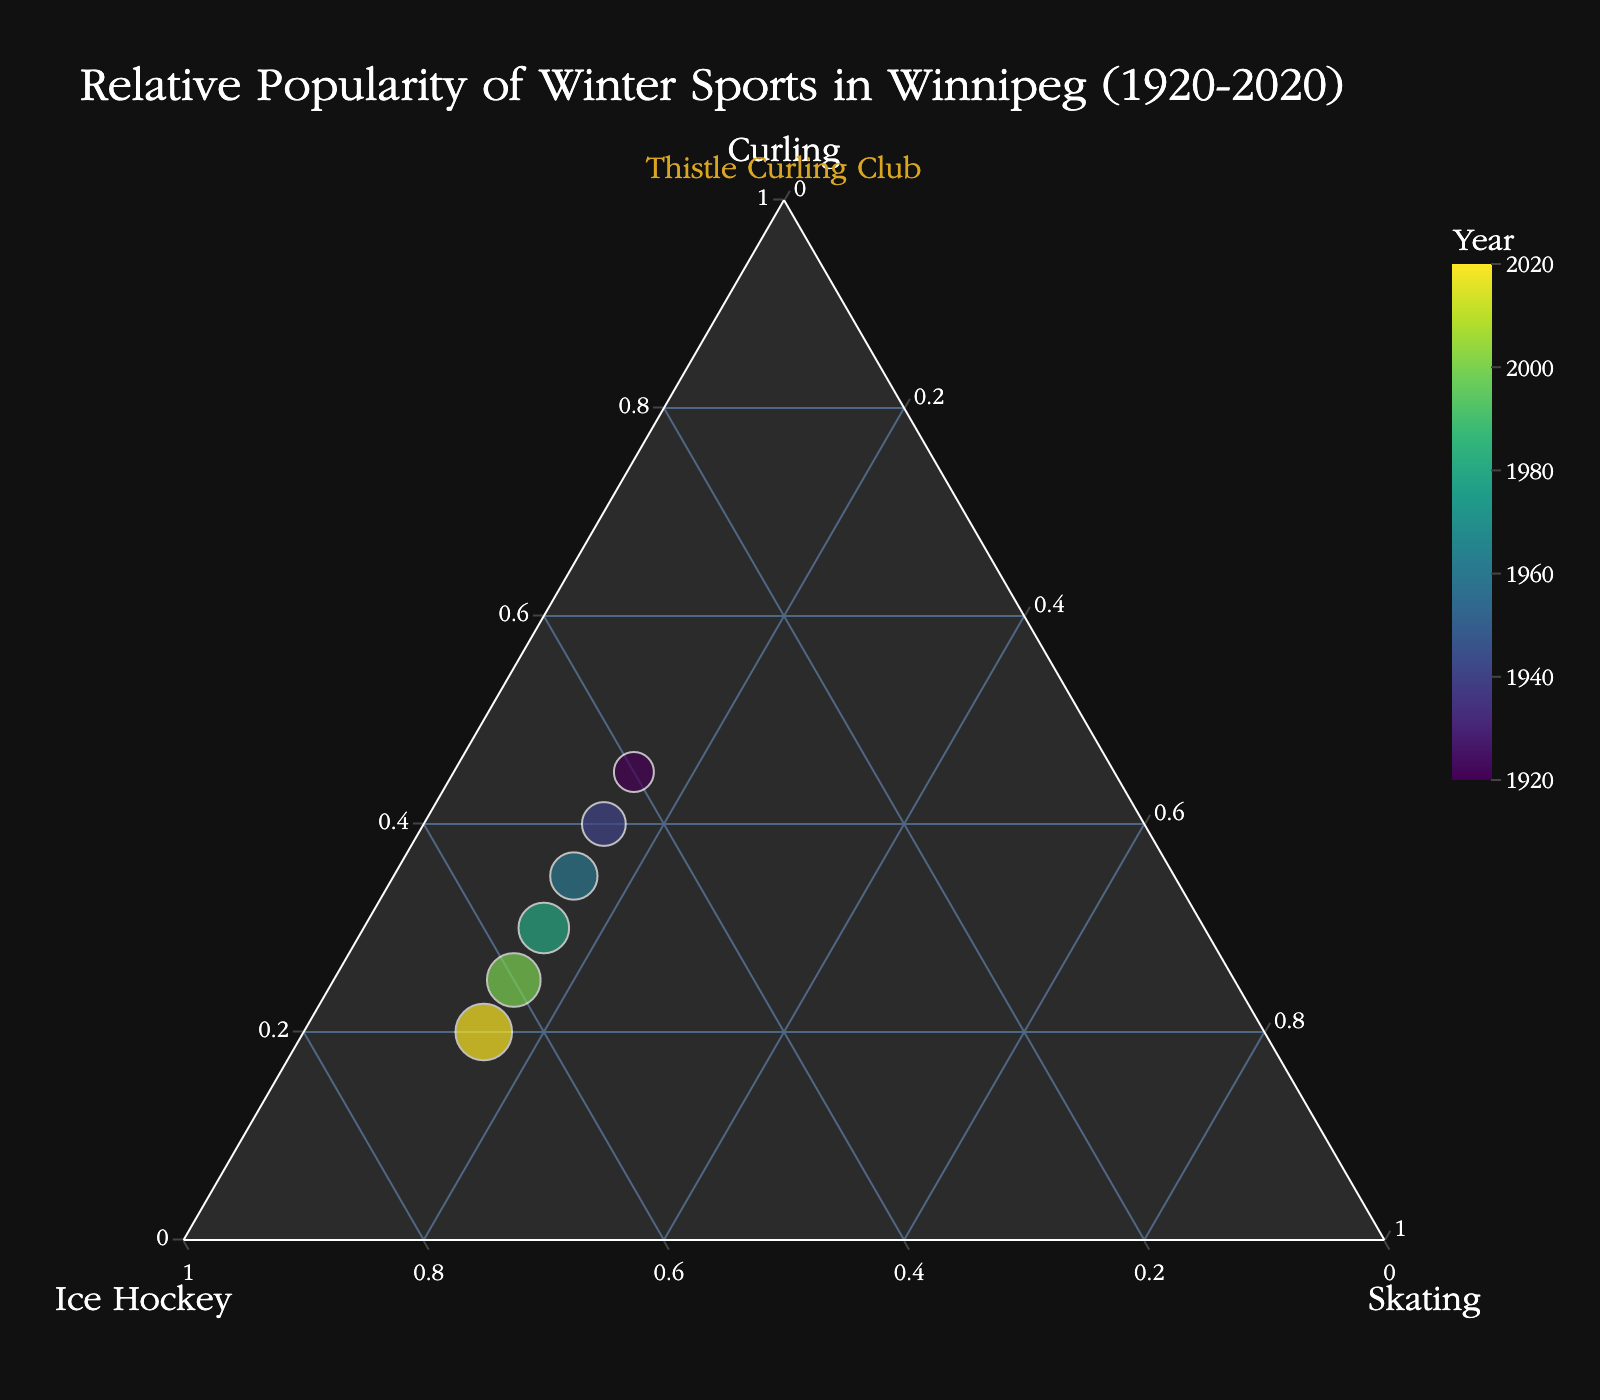What's the title of the figure? The title is at the top of the figure, usually in a larger font size. It is: "Relative Popularity of Winter Sports in Winnipeg (1920-2020)"
Answer: Relative Popularity of Winter Sports in Winnipeg (1920-2020) How many data points are represented in the ternary plot? Each data point represents a year listed in the data, and they appear as circles on the plot. Counting the circles, we see there are 6 data points.
Answer: 6 How has the popularity of curling changed over the years? By observing the plot, you can see that the position of curling on the ternary plot has shifted towards less popularity over the years. Initially, it had 45% popularity in 1920 and decreased to 20% by 2020.
Answer: Decreased Which sport was most popular in 1980? Each point's position in the ternary plot shows the proportional popularity of the three sports for that year. In 1980, the plot shows the highest value is for Ice Hockey.
Answer: Ice Hockey What is the trend in the popularity of ice hockey from 1920 to 2020? By tracing the position of the data points corresponding to each year on the ternary plot, it's clear that the percentage for ice hockey increases steadily from 40% in 1920 to 65% in 2020.
Answer: Increasing Between 1960 and 1980, which sport's popularity remained constant? Looking at the positions for 1960 and 1980, skating's position does not change, indicating a constant popularity of 15%.
Answer: Skating Compare the popularity of curling and ice hockey in 1920. Which was more popular, and by how much? Check the coordinates for the year 1920; curling is at 45% and ice hockey is at 40%. Curling was more popular by 5%.
Answer: Curling by 5% What does the size of the circles in the ternary plot represent? According to the data provided, the size of the circles increases with each decade. Larger circles indicate more recent years.
Answer: More recent years What is the relative composition of sports popularity in the year 2000? Observe the position on the ternary plot for the year 2000. It indicates 25% curling, 60% ice hockey, and 15% skating.
Answer: Curling: 25%, Ice Hockey: 60%, Skating: 15% By how much did the popularity of curling decrease from 1920 to 2020? Curling's popularity was 45% in 1920 and 20% in 2020. The decrease is calculated by subtracting 20% from 45%, which gives 25%.
Answer: 25% 